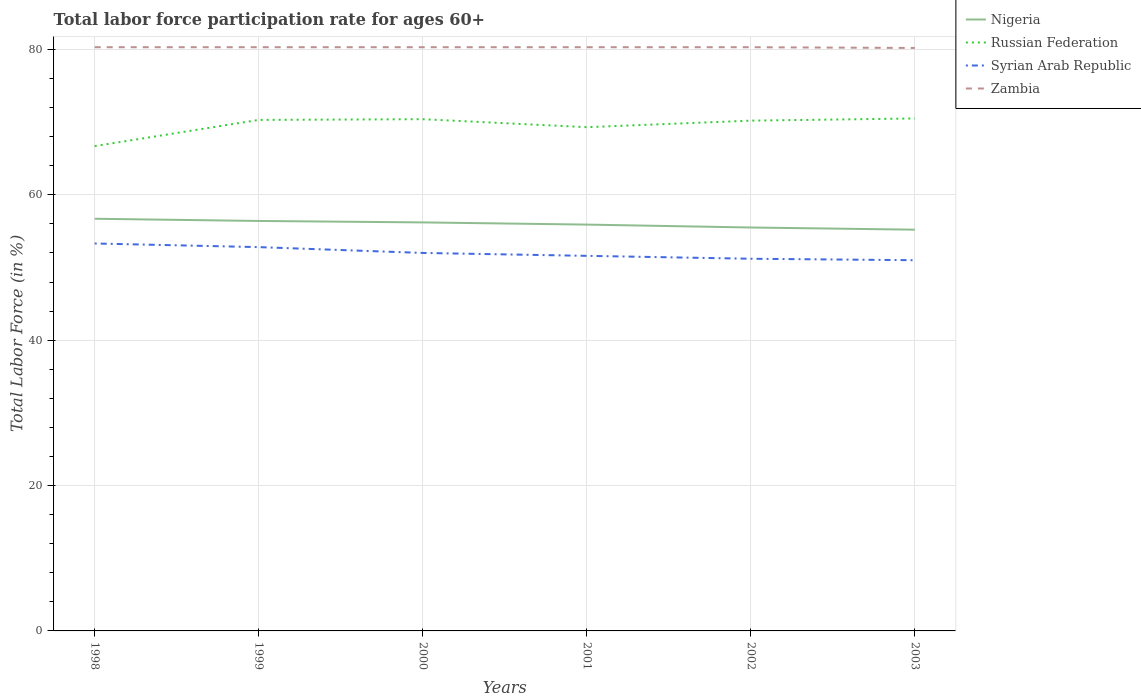Is the number of lines equal to the number of legend labels?
Keep it short and to the point. Yes. Across all years, what is the maximum labor force participation rate in Russian Federation?
Provide a succinct answer. 66.7. In which year was the labor force participation rate in Russian Federation maximum?
Provide a short and direct response. 1998. What is the total labor force participation rate in Russian Federation in the graph?
Your answer should be very brief. -3.6. What is the difference between the highest and the second highest labor force participation rate in Russian Federation?
Give a very brief answer. 3.8. Is the labor force participation rate in Syrian Arab Republic strictly greater than the labor force participation rate in Russian Federation over the years?
Give a very brief answer. Yes. How many lines are there?
Provide a succinct answer. 4. What is the difference between two consecutive major ticks on the Y-axis?
Ensure brevity in your answer.  20. Are the values on the major ticks of Y-axis written in scientific E-notation?
Offer a terse response. No. Does the graph contain any zero values?
Your answer should be compact. No. How are the legend labels stacked?
Offer a terse response. Vertical. What is the title of the graph?
Ensure brevity in your answer.  Total labor force participation rate for ages 60+. Does "Cyprus" appear as one of the legend labels in the graph?
Your response must be concise. No. What is the label or title of the Y-axis?
Provide a succinct answer. Total Labor Force (in %). What is the Total Labor Force (in %) in Nigeria in 1998?
Offer a very short reply. 56.7. What is the Total Labor Force (in %) of Russian Federation in 1998?
Keep it short and to the point. 66.7. What is the Total Labor Force (in %) of Syrian Arab Republic in 1998?
Provide a succinct answer. 53.3. What is the Total Labor Force (in %) of Zambia in 1998?
Give a very brief answer. 80.3. What is the Total Labor Force (in %) of Nigeria in 1999?
Keep it short and to the point. 56.4. What is the Total Labor Force (in %) of Russian Federation in 1999?
Your answer should be compact. 70.3. What is the Total Labor Force (in %) of Syrian Arab Republic in 1999?
Provide a succinct answer. 52.8. What is the Total Labor Force (in %) in Zambia in 1999?
Your response must be concise. 80.3. What is the Total Labor Force (in %) of Nigeria in 2000?
Your response must be concise. 56.2. What is the Total Labor Force (in %) in Russian Federation in 2000?
Provide a succinct answer. 70.4. What is the Total Labor Force (in %) in Syrian Arab Republic in 2000?
Provide a succinct answer. 52. What is the Total Labor Force (in %) in Zambia in 2000?
Your response must be concise. 80.3. What is the Total Labor Force (in %) of Nigeria in 2001?
Ensure brevity in your answer.  55.9. What is the Total Labor Force (in %) of Russian Federation in 2001?
Your response must be concise. 69.3. What is the Total Labor Force (in %) in Syrian Arab Republic in 2001?
Provide a short and direct response. 51.6. What is the Total Labor Force (in %) of Zambia in 2001?
Give a very brief answer. 80.3. What is the Total Labor Force (in %) of Nigeria in 2002?
Your response must be concise. 55.5. What is the Total Labor Force (in %) of Russian Federation in 2002?
Give a very brief answer. 70.2. What is the Total Labor Force (in %) in Syrian Arab Republic in 2002?
Make the answer very short. 51.2. What is the Total Labor Force (in %) in Zambia in 2002?
Provide a succinct answer. 80.3. What is the Total Labor Force (in %) of Nigeria in 2003?
Provide a succinct answer. 55.2. What is the Total Labor Force (in %) of Russian Federation in 2003?
Make the answer very short. 70.5. What is the Total Labor Force (in %) in Zambia in 2003?
Your answer should be compact. 80.2. Across all years, what is the maximum Total Labor Force (in %) in Nigeria?
Provide a short and direct response. 56.7. Across all years, what is the maximum Total Labor Force (in %) in Russian Federation?
Your answer should be compact. 70.5. Across all years, what is the maximum Total Labor Force (in %) in Syrian Arab Republic?
Your response must be concise. 53.3. Across all years, what is the maximum Total Labor Force (in %) of Zambia?
Provide a short and direct response. 80.3. Across all years, what is the minimum Total Labor Force (in %) in Nigeria?
Ensure brevity in your answer.  55.2. Across all years, what is the minimum Total Labor Force (in %) of Russian Federation?
Offer a terse response. 66.7. Across all years, what is the minimum Total Labor Force (in %) of Syrian Arab Republic?
Your answer should be compact. 51. Across all years, what is the minimum Total Labor Force (in %) of Zambia?
Your answer should be compact. 80.2. What is the total Total Labor Force (in %) of Nigeria in the graph?
Ensure brevity in your answer.  335.9. What is the total Total Labor Force (in %) in Russian Federation in the graph?
Offer a very short reply. 417.4. What is the total Total Labor Force (in %) in Syrian Arab Republic in the graph?
Ensure brevity in your answer.  311.9. What is the total Total Labor Force (in %) of Zambia in the graph?
Your answer should be very brief. 481.7. What is the difference between the Total Labor Force (in %) in Nigeria in 1998 and that in 1999?
Provide a short and direct response. 0.3. What is the difference between the Total Labor Force (in %) in Russian Federation in 1998 and that in 1999?
Offer a terse response. -3.6. What is the difference between the Total Labor Force (in %) of Nigeria in 1998 and that in 2000?
Your answer should be compact. 0.5. What is the difference between the Total Labor Force (in %) in Zambia in 1998 and that in 2000?
Make the answer very short. 0. What is the difference between the Total Labor Force (in %) of Russian Federation in 1998 and that in 2002?
Your response must be concise. -3.5. What is the difference between the Total Labor Force (in %) in Syrian Arab Republic in 1998 and that in 2003?
Provide a succinct answer. 2.3. What is the difference between the Total Labor Force (in %) in Zambia in 1998 and that in 2003?
Ensure brevity in your answer.  0.1. What is the difference between the Total Labor Force (in %) of Nigeria in 1999 and that in 2000?
Offer a very short reply. 0.2. What is the difference between the Total Labor Force (in %) in Russian Federation in 1999 and that in 2000?
Offer a terse response. -0.1. What is the difference between the Total Labor Force (in %) in Zambia in 1999 and that in 2000?
Your answer should be compact. 0. What is the difference between the Total Labor Force (in %) of Russian Federation in 1999 and that in 2001?
Make the answer very short. 1. What is the difference between the Total Labor Force (in %) in Zambia in 1999 and that in 2001?
Your answer should be compact. 0. What is the difference between the Total Labor Force (in %) of Nigeria in 1999 and that in 2002?
Ensure brevity in your answer.  0.9. What is the difference between the Total Labor Force (in %) of Russian Federation in 1999 and that in 2002?
Your answer should be compact. 0.1. What is the difference between the Total Labor Force (in %) of Syrian Arab Republic in 1999 and that in 2002?
Provide a short and direct response. 1.6. What is the difference between the Total Labor Force (in %) of Nigeria in 1999 and that in 2003?
Offer a terse response. 1.2. What is the difference between the Total Labor Force (in %) in Syrian Arab Republic in 1999 and that in 2003?
Offer a very short reply. 1.8. What is the difference between the Total Labor Force (in %) of Nigeria in 2000 and that in 2001?
Ensure brevity in your answer.  0.3. What is the difference between the Total Labor Force (in %) in Russian Federation in 2000 and that in 2001?
Your answer should be very brief. 1.1. What is the difference between the Total Labor Force (in %) of Syrian Arab Republic in 2000 and that in 2001?
Provide a succinct answer. 0.4. What is the difference between the Total Labor Force (in %) of Zambia in 2000 and that in 2001?
Offer a very short reply. 0. What is the difference between the Total Labor Force (in %) in Syrian Arab Republic in 2000 and that in 2002?
Provide a succinct answer. 0.8. What is the difference between the Total Labor Force (in %) in Nigeria in 2000 and that in 2003?
Your response must be concise. 1. What is the difference between the Total Labor Force (in %) of Syrian Arab Republic in 2000 and that in 2003?
Provide a short and direct response. 1. What is the difference between the Total Labor Force (in %) of Zambia in 2000 and that in 2003?
Provide a short and direct response. 0.1. What is the difference between the Total Labor Force (in %) in Russian Federation in 2001 and that in 2002?
Keep it short and to the point. -0.9. What is the difference between the Total Labor Force (in %) of Syrian Arab Republic in 2001 and that in 2002?
Ensure brevity in your answer.  0.4. What is the difference between the Total Labor Force (in %) in Zambia in 2001 and that in 2002?
Keep it short and to the point. 0. What is the difference between the Total Labor Force (in %) in Nigeria in 2001 and that in 2003?
Your response must be concise. 0.7. What is the difference between the Total Labor Force (in %) in Syrian Arab Republic in 2001 and that in 2003?
Offer a terse response. 0.6. What is the difference between the Total Labor Force (in %) in Syrian Arab Republic in 2002 and that in 2003?
Your response must be concise. 0.2. What is the difference between the Total Labor Force (in %) in Nigeria in 1998 and the Total Labor Force (in %) in Russian Federation in 1999?
Your answer should be very brief. -13.6. What is the difference between the Total Labor Force (in %) of Nigeria in 1998 and the Total Labor Force (in %) of Syrian Arab Republic in 1999?
Your answer should be very brief. 3.9. What is the difference between the Total Labor Force (in %) in Nigeria in 1998 and the Total Labor Force (in %) in Zambia in 1999?
Your answer should be very brief. -23.6. What is the difference between the Total Labor Force (in %) of Russian Federation in 1998 and the Total Labor Force (in %) of Syrian Arab Republic in 1999?
Provide a succinct answer. 13.9. What is the difference between the Total Labor Force (in %) of Russian Federation in 1998 and the Total Labor Force (in %) of Zambia in 1999?
Keep it short and to the point. -13.6. What is the difference between the Total Labor Force (in %) in Nigeria in 1998 and the Total Labor Force (in %) in Russian Federation in 2000?
Provide a short and direct response. -13.7. What is the difference between the Total Labor Force (in %) in Nigeria in 1998 and the Total Labor Force (in %) in Syrian Arab Republic in 2000?
Ensure brevity in your answer.  4.7. What is the difference between the Total Labor Force (in %) in Nigeria in 1998 and the Total Labor Force (in %) in Zambia in 2000?
Offer a terse response. -23.6. What is the difference between the Total Labor Force (in %) of Russian Federation in 1998 and the Total Labor Force (in %) of Syrian Arab Republic in 2000?
Make the answer very short. 14.7. What is the difference between the Total Labor Force (in %) in Russian Federation in 1998 and the Total Labor Force (in %) in Zambia in 2000?
Your answer should be very brief. -13.6. What is the difference between the Total Labor Force (in %) of Syrian Arab Republic in 1998 and the Total Labor Force (in %) of Zambia in 2000?
Your response must be concise. -27. What is the difference between the Total Labor Force (in %) in Nigeria in 1998 and the Total Labor Force (in %) in Russian Federation in 2001?
Keep it short and to the point. -12.6. What is the difference between the Total Labor Force (in %) in Nigeria in 1998 and the Total Labor Force (in %) in Zambia in 2001?
Provide a succinct answer. -23.6. What is the difference between the Total Labor Force (in %) of Nigeria in 1998 and the Total Labor Force (in %) of Russian Federation in 2002?
Your answer should be compact. -13.5. What is the difference between the Total Labor Force (in %) in Nigeria in 1998 and the Total Labor Force (in %) in Zambia in 2002?
Your answer should be very brief. -23.6. What is the difference between the Total Labor Force (in %) in Russian Federation in 1998 and the Total Labor Force (in %) in Syrian Arab Republic in 2002?
Your answer should be very brief. 15.5. What is the difference between the Total Labor Force (in %) in Russian Federation in 1998 and the Total Labor Force (in %) in Zambia in 2002?
Ensure brevity in your answer.  -13.6. What is the difference between the Total Labor Force (in %) in Syrian Arab Republic in 1998 and the Total Labor Force (in %) in Zambia in 2002?
Give a very brief answer. -27. What is the difference between the Total Labor Force (in %) in Nigeria in 1998 and the Total Labor Force (in %) in Russian Federation in 2003?
Your answer should be compact. -13.8. What is the difference between the Total Labor Force (in %) of Nigeria in 1998 and the Total Labor Force (in %) of Zambia in 2003?
Offer a very short reply. -23.5. What is the difference between the Total Labor Force (in %) of Syrian Arab Republic in 1998 and the Total Labor Force (in %) of Zambia in 2003?
Make the answer very short. -26.9. What is the difference between the Total Labor Force (in %) in Nigeria in 1999 and the Total Labor Force (in %) in Russian Federation in 2000?
Give a very brief answer. -14. What is the difference between the Total Labor Force (in %) of Nigeria in 1999 and the Total Labor Force (in %) of Syrian Arab Republic in 2000?
Provide a short and direct response. 4.4. What is the difference between the Total Labor Force (in %) in Nigeria in 1999 and the Total Labor Force (in %) in Zambia in 2000?
Your answer should be compact. -23.9. What is the difference between the Total Labor Force (in %) in Russian Federation in 1999 and the Total Labor Force (in %) in Zambia in 2000?
Offer a terse response. -10. What is the difference between the Total Labor Force (in %) of Syrian Arab Republic in 1999 and the Total Labor Force (in %) of Zambia in 2000?
Offer a terse response. -27.5. What is the difference between the Total Labor Force (in %) of Nigeria in 1999 and the Total Labor Force (in %) of Syrian Arab Republic in 2001?
Provide a succinct answer. 4.8. What is the difference between the Total Labor Force (in %) in Nigeria in 1999 and the Total Labor Force (in %) in Zambia in 2001?
Provide a succinct answer. -23.9. What is the difference between the Total Labor Force (in %) of Russian Federation in 1999 and the Total Labor Force (in %) of Syrian Arab Republic in 2001?
Keep it short and to the point. 18.7. What is the difference between the Total Labor Force (in %) of Syrian Arab Republic in 1999 and the Total Labor Force (in %) of Zambia in 2001?
Your response must be concise. -27.5. What is the difference between the Total Labor Force (in %) of Nigeria in 1999 and the Total Labor Force (in %) of Russian Federation in 2002?
Provide a short and direct response. -13.8. What is the difference between the Total Labor Force (in %) in Nigeria in 1999 and the Total Labor Force (in %) in Syrian Arab Republic in 2002?
Make the answer very short. 5.2. What is the difference between the Total Labor Force (in %) of Nigeria in 1999 and the Total Labor Force (in %) of Zambia in 2002?
Your response must be concise. -23.9. What is the difference between the Total Labor Force (in %) in Russian Federation in 1999 and the Total Labor Force (in %) in Syrian Arab Republic in 2002?
Provide a short and direct response. 19.1. What is the difference between the Total Labor Force (in %) of Syrian Arab Republic in 1999 and the Total Labor Force (in %) of Zambia in 2002?
Give a very brief answer. -27.5. What is the difference between the Total Labor Force (in %) of Nigeria in 1999 and the Total Labor Force (in %) of Russian Federation in 2003?
Keep it short and to the point. -14.1. What is the difference between the Total Labor Force (in %) of Nigeria in 1999 and the Total Labor Force (in %) of Zambia in 2003?
Make the answer very short. -23.8. What is the difference between the Total Labor Force (in %) in Russian Federation in 1999 and the Total Labor Force (in %) in Syrian Arab Republic in 2003?
Ensure brevity in your answer.  19.3. What is the difference between the Total Labor Force (in %) in Russian Federation in 1999 and the Total Labor Force (in %) in Zambia in 2003?
Make the answer very short. -9.9. What is the difference between the Total Labor Force (in %) of Syrian Arab Republic in 1999 and the Total Labor Force (in %) of Zambia in 2003?
Offer a very short reply. -27.4. What is the difference between the Total Labor Force (in %) in Nigeria in 2000 and the Total Labor Force (in %) in Syrian Arab Republic in 2001?
Keep it short and to the point. 4.6. What is the difference between the Total Labor Force (in %) of Nigeria in 2000 and the Total Labor Force (in %) of Zambia in 2001?
Provide a succinct answer. -24.1. What is the difference between the Total Labor Force (in %) of Russian Federation in 2000 and the Total Labor Force (in %) of Syrian Arab Republic in 2001?
Provide a short and direct response. 18.8. What is the difference between the Total Labor Force (in %) in Syrian Arab Republic in 2000 and the Total Labor Force (in %) in Zambia in 2001?
Your response must be concise. -28.3. What is the difference between the Total Labor Force (in %) of Nigeria in 2000 and the Total Labor Force (in %) of Russian Federation in 2002?
Keep it short and to the point. -14. What is the difference between the Total Labor Force (in %) of Nigeria in 2000 and the Total Labor Force (in %) of Zambia in 2002?
Your response must be concise. -24.1. What is the difference between the Total Labor Force (in %) of Russian Federation in 2000 and the Total Labor Force (in %) of Syrian Arab Republic in 2002?
Offer a very short reply. 19.2. What is the difference between the Total Labor Force (in %) of Syrian Arab Republic in 2000 and the Total Labor Force (in %) of Zambia in 2002?
Your response must be concise. -28.3. What is the difference between the Total Labor Force (in %) in Nigeria in 2000 and the Total Labor Force (in %) in Russian Federation in 2003?
Give a very brief answer. -14.3. What is the difference between the Total Labor Force (in %) of Nigeria in 2000 and the Total Labor Force (in %) of Syrian Arab Republic in 2003?
Offer a very short reply. 5.2. What is the difference between the Total Labor Force (in %) of Nigeria in 2000 and the Total Labor Force (in %) of Zambia in 2003?
Offer a terse response. -24. What is the difference between the Total Labor Force (in %) in Syrian Arab Republic in 2000 and the Total Labor Force (in %) in Zambia in 2003?
Provide a short and direct response. -28.2. What is the difference between the Total Labor Force (in %) of Nigeria in 2001 and the Total Labor Force (in %) of Russian Federation in 2002?
Offer a very short reply. -14.3. What is the difference between the Total Labor Force (in %) of Nigeria in 2001 and the Total Labor Force (in %) of Syrian Arab Republic in 2002?
Keep it short and to the point. 4.7. What is the difference between the Total Labor Force (in %) of Nigeria in 2001 and the Total Labor Force (in %) of Zambia in 2002?
Ensure brevity in your answer.  -24.4. What is the difference between the Total Labor Force (in %) of Russian Federation in 2001 and the Total Labor Force (in %) of Syrian Arab Republic in 2002?
Your answer should be compact. 18.1. What is the difference between the Total Labor Force (in %) in Syrian Arab Republic in 2001 and the Total Labor Force (in %) in Zambia in 2002?
Offer a terse response. -28.7. What is the difference between the Total Labor Force (in %) of Nigeria in 2001 and the Total Labor Force (in %) of Russian Federation in 2003?
Offer a terse response. -14.6. What is the difference between the Total Labor Force (in %) in Nigeria in 2001 and the Total Labor Force (in %) in Zambia in 2003?
Provide a succinct answer. -24.3. What is the difference between the Total Labor Force (in %) in Syrian Arab Republic in 2001 and the Total Labor Force (in %) in Zambia in 2003?
Keep it short and to the point. -28.6. What is the difference between the Total Labor Force (in %) of Nigeria in 2002 and the Total Labor Force (in %) of Russian Federation in 2003?
Your response must be concise. -15. What is the difference between the Total Labor Force (in %) in Nigeria in 2002 and the Total Labor Force (in %) in Zambia in 2003?
Ensure brevity in your answer.  -24.7. What is the difference between the Total Labor Force (in %) of Syrian Arab Republic in 2002 and the Total Labor Force (in %) of Zambia in 2003?
Offer a terse response. -29. What is the average Total Labor Force (in %) of Nigeria per year?
Offer a terse response. 55.98. What is the average Total Labor Force (in %) of Russian Federation per year?
Your answer should be very brief. 69.57. What is the average Total Labor Force (in %) in Syrian Arab Republic per year?
Ensure brevity in your answer.  51.98. What is the average Total Labor Force (in %) in Zambia per year?
Provide a succinct answer. 80.28. In the year 1998, what is the difference between the Total Labor Force (in %) in Nigeria and Total Labor Force (in %) in Syrian Arab Republic?
Provide a short and direct response. 3.4. In the year 1998, what is the difference between the Total Labor Force (in %) in Nigeria and Total Labor Force (in %) in Zambia?
Your response must be concise. -23.6. In the year 1998, what is the difference between the Total Labor Force (in %) in Russian Federation and Total Labor Force (in %) in Syrian Arab Republic?
Your answer should be compact. 13.4. In the year 1999, what is the difference between the Total Labor Force (in %) in Nigeria and Total Labor Force (in %) in Russian Federation?
Ensure brevity in your answer.  -13.9. In the year 1999, what is the difference between the Total Labor Force (in %) in Nigeria and Total Labor Force (in %) in Zambia?
Provide a short and direct response. -23.9. In the year 1999, what is the difference between the Total Labor Force (in %) of Russian Federation and Total Labor Force (in %) of Zambia?
Your answer should be compact. -10. In the year 1999, what is the difference between the Total Labor Force (in %) of Syrian Arab Republic and Total Labor Force (in %) of Zambia?
Offer a very short reply. -27.5. In the year 2000, what is the difference between the Total Labor Force (in %) of Nigeria and Total Labor Force (in %) of Russian Federation?
Provide a short and direct response. -14.2. In the year 2000, what is the difference between the Total Labor Force (in %) in Nigeria and Total Labor Force (in %) in Syrian Arab Republic?
Make the answer very short. 4.2. In the year 2000, what is the difference between the Total Labor Force (in %) of Nigeria and Total Labor Force (in %) of Zambia?
Offer a very short reply. -24.1. In the year 2000, what is the difference between the Total Labor Force (in %) of Russian Federation and Total Labor Force (in %) of Syrian Arab Republic?
Ensure brevity in your answer.  18.4. In the year 2000, what is the difference between the Total Labor Force (in %) in Syrian Arab Republic and Total Labor Force (in %) in Zambia?
Your response must be concise. -28.3. In the year 2001, what is the difference between the Total Labor Force (in %) in Nigeria and Total Labor Force (in %) in Syrian Arab Republic?
Offer a terse response. 4.3. In the year 2001, what is the difference between the Total Labor Force (in %) in Nigeria and Total Labor Force (in %) in Zambia?
Provide a short and direct response. -24.4. In the year 2001, what is the difference between the Total Labor Force (in %) of Russian Federation and Total Labor Force (in %) of Syrian Arab Republic?
Keep it short and to the point. 17.7. In the year 2001, what is the difference between the Total Labor Force (in %) in Russian Federation and Total Labor Force (in %) in Zambia?
Your answer should be compact. -11. In the year 2001, what is the difference between the Total Labor Force (in %) in Syrian Arab Republic and Total Labor Force (in %) in Zambia?
Provide a succinct answer. -28.7. In the year 2002, what is the difference between the Total Labor Force (in %) of Nigeria and Total Labor Force (in %) of Russian Federation?
Make the answer very short. -14.7. In the year 2002, what is the difference between the Total Labor Force (in %) of Nigeria and Total Labor Force (in %) of Syrian Arab Republic?
Your answer should be very brief. 4.3. In the year 2002, what is the difference between the Total Labor Force (in %) in Nigeria and Total Labor Force (in %) in Zambia?
Give a very brief answer. -24.8. In the year 2002, what is the difference between the Total Labor Force (in %) of Russian Federation and Total Labor Force (in %) of Zambia?
Offer a very short reply. -10.1. In the year 2002, what is the difference between the Total Labor Force (in %) of Syrian Arab Republic and Total Labor Force (in %) of Zambia?
Your answer should be compact. -29.1. In the year 2003, what is the difference between the Total Labor Force (in %) in Nigeria and Total Labor Force (in %) in Russian Federation?
Your response must be concise. -15.3. In the year 2003, what is the difference between the Total Labor Force (in %) in Nigeria and Total Labor Force (in %) in Zambia?
Your response must be concise. -25. In the year 2003, what is the difference between the Total Labor Force (in %) of Syrian Arab Republic and Total Labor Force (in %) of Zambia?
Provide a succinct answer. -29.2. What is the ratio of the Total Labor Force (in %) in Nigeria in 1998 to that in 1999?
Ensure brevity in your answer.  1.01. What is the ratio of the Total Labor Force (in %) in Russian Federation in 1998 to that in 1999?
Offer a terse response. 0.95. What is the ratio of the Total Labor Force (in %) in Syrian Arab Republic in 1998 to that in 1999?
Offer a very short reply. 1.01. What is the ratio of the Total Labor Force (in %) of Nigeria in 1998 to that in 2000?
Your answer should be compact. 1.01. What is the ratio of the Total Labor Force (in %) of Syrian Arab Republic in 1998 to that in 2000?
Ensure brevity in your answer.  1.02. What is the ratio of the Total Labor Force (in %) of Zambia in 1998 to that in 2000?
Provide a succinct answer. 1. What is the ratio of the Total Labor Force (in %) of Nigeria in 1998 to that in 2001?
Ensure brevity in your answer.  1.01. What is the ratio of the Total Labor Force (in %) of Russian Federation in 1998 to that in 2001?
Make the answer very short. 0.96. What is the ratio of the Total Labor Force (in %) of Syrian Arab Republic in 1998 to that in 2001?
Keep it short and to the point. 1.03. What is the ratio of the Total Labor Force (in %) in Zambia in 1998 to that in 2001?
Offer a terse response. 1. What is the ratio of the Total Labor Force (in %) of Nigeria in 1998 to that in 2002?
Your answer should be compact. 1.02. What is the ratio of the Total Labor Force (in %) in Russian Federation in 1998 to that in 2002?
Give a very brief answer. 0.95. What is the ratio of the Total Labor Force (in %) of Syrian Arab Republic in 1998 to that in 2002?
Give a very brief answer. 1.04. What is the ratio of the Total Labor Force (in %) of Nigeria in 1998 to that in 2003?
Your response must be concise. 1.03. What is the ratio of the Total Labor Force (in %) of Russian Federation in 1998 to that in 2003?
Keep it short and to the point. 0.95. What is the ratio of the Total Labor Force (in %) in Syrian Arab Republic in 1998 to that in 2003?
Keep it short and to the point. 1.05. What is the ratio of the Total Labor Force (in %) of Syrian Arab Republic in 1999 to that in 2000?
Keep it short and to the point. 1.02. What is the ratio of the Total Labor Force (in %) in Zambia in 1999 to that in 2000?
Provide a short and direct response. 1. What is the ratio of the Total Labor Force (in %) of Nigeria in 1999 to that in 2001?
Offer a terse response. 1.01. What is the ratio of the Total Labor Force (in %) in Russian Federation in 1999 to that in 2001?
Offer a very short reply. 1.01. What is the ratio of the Total Labor Force (in %) of Syrian Arab Republic in 1999 to that in 2001?
Give a very brief answer. 1.02. What is the ratio of the Total Labor Force (in %) in Zambia in 1999 to that in 2001?
Keep it short and to the point. 1. What is the ratio of the Total Labor Force (in %) of Nigeria in 1999 to that in 2002?
Your answer should be very brief. 1.02. What is the ratio of the Total Labor Force (in %) of Syrian Arab Republic in 1999 to that in 2002?
Keep it short and to the point. 1.03. What is the ratio of the Total Labor Force (in %) of Zambia in 1999 to that in 2002?
Your response must be concise. 1. What is the ratio of the Total Labor Force (in %) of Nigeria in 1999 to that in 2003?
Your answer should be compact. 1.02. What is the ratio of the Total Labor Force (in %) of Russian Federation in 1999 to that in 2003?
Keep it short and to the point. 1. What is the ratio of the Total Labor Force (in %) of Syrian Arab Republic in 1999 to that in 2003?
Keep it short and to the point. 1.04. What is the ratio of the Total Labor Force (in %) in Nigeria in 2000 to that in 2001?
Ensure brevity in your answer.  1.01. What is the ratio of the Total Labor Force (in %) in Russian Federation in 2000 to that in 2001?
Give a very brief answer. 1.02. What is the ratio of the Total Labor Force (in %) of Zambia in 2000 to that in 2001?
Offer a very short reply. 1. What is the ratio of the Total Labor Force (in %) in Nigeria in 2000 to that in 2002?
Your response must be concise. 1.01. What is the ratio of the Total Labor Force (in %) in Russian Federation in 2000 to that in 2002?
Offer a terse response. 1. What is the ratio of the Total Labor Force (in %) in Syrian Arab Republic in 2000 to that in 2002?
Provide a short and direct response. 1.02. What is the ratio of the Total Labor Force (in %) of Nigeria in 2000 to that in 2003?
Your answer should be compact. 1.02. What is the ratio of the Total Labor Force (in %) in Syrian Arab Republic in 2000 to that in 2003?
Provide a succinct answer. 1.02. What is the ratio of the Total Labor Force (in %) in Russian Federation in 2001 to that in 2002?
Your answer should be compact. 0.99. What is the ratio of the Total Labor Force (in %) in Syrian Arab Republic in 2001 to that in 2002?
Make the answer very short. 1.01. What is the ratio of the Total Labor Force (in %) of Nigeria in 2001 to that in 2003?
Make the answer very short. 1.01. What is the ratio of the Total Labor Force (in %) in Syrian Arab Republic in 2001 to that in 2003?
Your answer should be very brief. 1.01. What is the ratio of the Total Labor Force (in %) of Nigeria in 2002 to that in 2003?
Your response must be concise. 1.01. What is the ratio of the Total Labor Force (in %) of Syrian Arab Republic in 2002 to that in 2003?
Your response must be concise. 1. What is the difference between the highest and the second highest Total Labor Force (in %) in Russian Federation?
Make the answer very short. 0.1. What is the difference between the highest and the second highest Total Labor Force (in %) in Syrian Arab Republic?
Offer a terse response. 0.5. What is the difference between the highest and the second highest Total Labor Force (in %) in Zambia?
Keep it short and to the point. 0. What is the difference between the highest and the lowest Total Labor Force (in %) in Nigeria?
Keep it short and to the point. 1.5. What is the difference between the highest and the lowest Total Labor Force (in %) in Russian Federation?
Give a very brief answer. 3.8. What is the difference between the highest and the lowest Total Labor Force (in %) in Zambia?
Give a very brief answer. 0.1. 